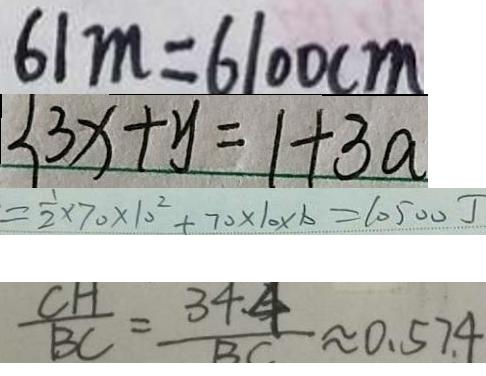Convert formula to latex. <formula><loc_0><loc_0><loc_500><loc_500>6 1 m = 6 1 0 0 c m 
 \{ 3 x + y = 1 + 3 a 
 = \frac { 1 } { 2 } \times 7 0 \times 1 0 ^ { 2 } + 7 0 \times 1 0 \times b = 1 0 5 0 0 J 
 \frac { C H } { B C } = \frac { 3 4 . 4 } { B C } \approx 0 . 5 7 4</formula> 